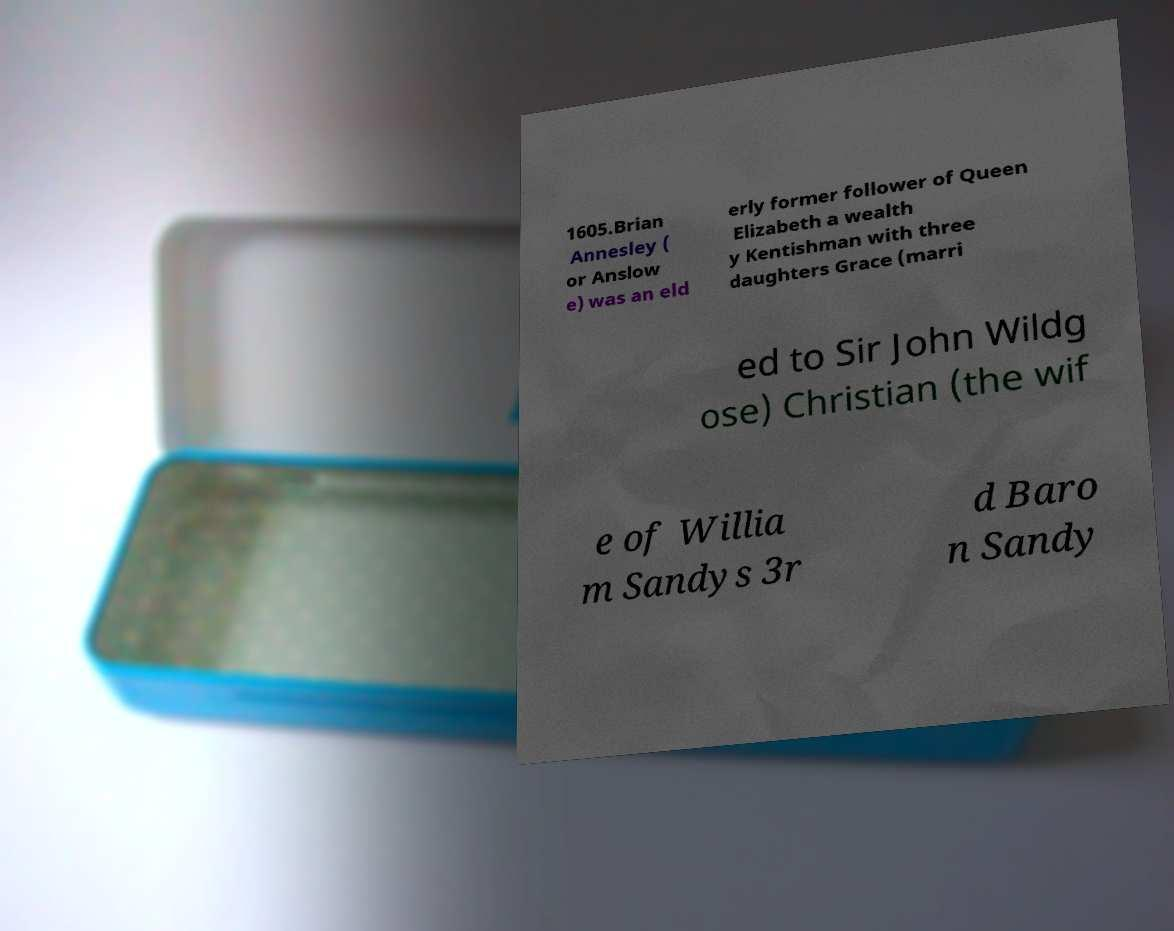I need the written content from this picture converted into text. Can you do that? 1605.Brian Annesley ( or Anslow e) was an eld erly former follower of Queen Elizabeth a wealth y Kentishman with three daughters Grace (marri ed to Sir John Wildg ose) Christian (the wif e of Willia m Sandys 3r d Baro n Sandy 